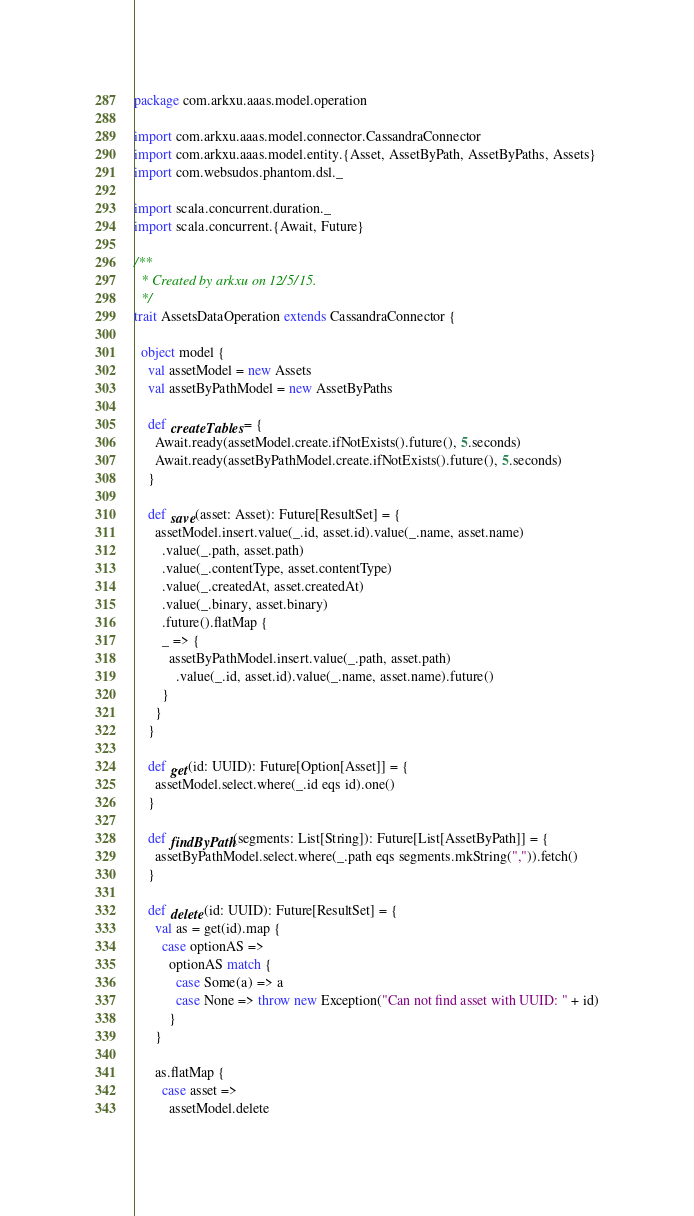Convert code to text. <code><loc_0><loc_0><loc_500><loc_500><_Scala_>package com.arkxu.aaas.model.operation

import com.arkxu.aaas.model.connector.CassandraConnector
import com.arkxu.aaas.model.entity.{Asset, AssetByPath, AssetByPaths, Assets}
import com.websudos.phantom.dsl._

import scala.concurrent.duration._
import scala.concurrent.{Await, Future}

/**
  * Created by arkxu on 12/5/15.
  */
trait AssetsDataOperation extends CassandraConnector {

  object model {
    val assetModel = new Assets
    val assetByPathModel = new AssetByPaths

    def createTables = {
      Await.ready(assetModel.create.ifNotExists().future(), 5.seconds)
      Await.ready(assetByPathModel.create.ifNotExists().future(), 5.seconds)
    }

    def save(asset: Asset): Future[ResultSet] = {
      assetModel.insert.value(_.id, asset.id).value(_.name, asset.name)
        .value(_.path, asset.path)
        .value(_.contentType, asset.contentType)
        .value(_.createdAt, asset.createdAt)
        .value(_.binary, asset.binary)
        .future().flatMap {
        _ => {
          assetByPathModel.insert.value(_.path, asset.path)
            .value(_.id, asset.id).value(_.name, asset.name).future()
        }
      }
    }

    def get(id: UUID): Future[Option[Asset]] = {
      assetModel.select.where(_.id eqs id).one()
    }

    def findByPath(segments: List[String]): Future[List[AssetByPath]] = {
      assetByPathModel.select.where(_.path eqs segments.mkString(",")).fetch()
    }

    def delete(id: UUID): Future[ResultSet] = {
      val as = get(id).map {
        case optionAS =>
          optionAS match {
            case Some(a) => a
            case None => throw new Exception("Can not find asset with UUID: " + id)
          }
      }

      as.flatMap {
        case asset =>
          assetModel.delete</code> 